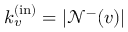Convert formula to latex. <formula><loc_0><loc_0><loc_500><loc_500>k _ { v } ^ { ( i n ) } = | \mathcal { N } ^ { - } ( v ) |</formula> 